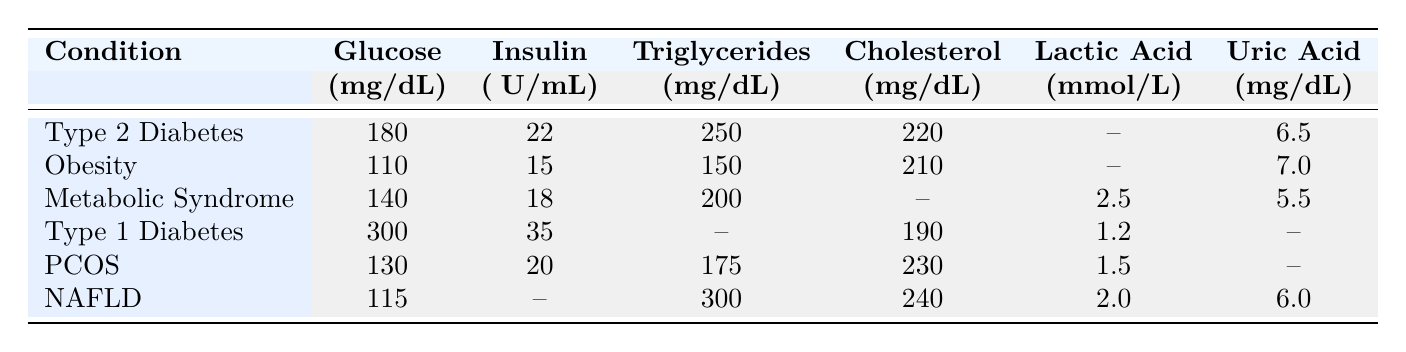What is the glucose concentration for patients with Type 2 Diabetes? According to the table, the glucose concentration for Type 2 Diabetes is listed as 180 mg/dL.
Answer: 180 mg/dL What is the insulin concentration for the patient with Type 1 Diabetes? The table shows that the insulin concentration for Type 1 Diabetes is 35 μU/mL.
Answer: 35 μU/mL How many patients have a triglyceride concentration greater than 200 mg/dL? Reviewing the table, the patients with triglyceride concentrations over 200 mg/dL are P1 (250 mg/dL), P3 (200 mg/dL contributes exactly 200 but does not exceed it), and P6 (300 mg/dL). Thus, there are 2 patients with triglycerides greater than 200 mg/dL.
Answer: 2 What is the average uric acid level of all patients listed? The uric acid levels are 6.5 (P1), 7.0 (P2), 5.5 (P3), null (P4), null (P5), and 6.0 (P6). The valid values are 6.5, 7.0, 5.5, and 6.0. The sum is (6.5 + 7.0 + 5.5 + 6.0) = 25.0, and there are 4 valid values, yielding an average of 25.0/4 = 6.25.
Answer: 6.25 mg/dL Is there any condition listed that has a cholesterol concentration lower than 200 mg/dL? Only the patient with Type 1 Diabetes has a cholesterol concentration of 190 mg/dL, which is below 200 mg/dL. Therefore, the answer is yes.
Answer: Yes Which condition has the highest glucose concentration and what is its value? In the table, Type 1 Diabetes has the highest glucose concentration recorded at 300 mg/dL, compared to other conditions.
Answer: Type 1 Diabetes; 300 mg/dL What is the difference in triglyceride concentrations between the patient with the highest and the lowest value? The highest triglyceride concentration is found in NAFLD with 300 mg/dL and the lowest is in Obesity with 150 mg/dL. The difference is calculated as 300 - 150 = 150 mg/dL.
Answer: 150 mg/dL Which patient has the lowest lactic acid level and what is that level? The table indicates that the lowest lactic acid level is 1.2 mmol/L for Type 1 Diabetes, displayed clearly in the respective row.
Answer: 1.2 mmol/L How many patients have a recorded lactic acid value? The applicable patients with lactic acid values listed are P3 (2.5 mmol/L), P4 (1.2 mmol/L), and P5 (1.5 mmol/L). Therefore, there are 3 patients with recorded lactic acid concentrations.
Answer: 3 Is the average glucose concentration for patients with metabolic disorders greater than 180 mg/dL? The glucose concentrations are 180 (P1), 110 (P2), 140 (P3), 300 (P4), 130 (P5), and 115 (P6). The sum of glucose levels is (180 + 110 + 140 + 300 + 130 + 115) = 975 and there are 6 patients, yielding an average of 975/6 = 162.5, which is less than 180 mg/dL.
Answer: No 